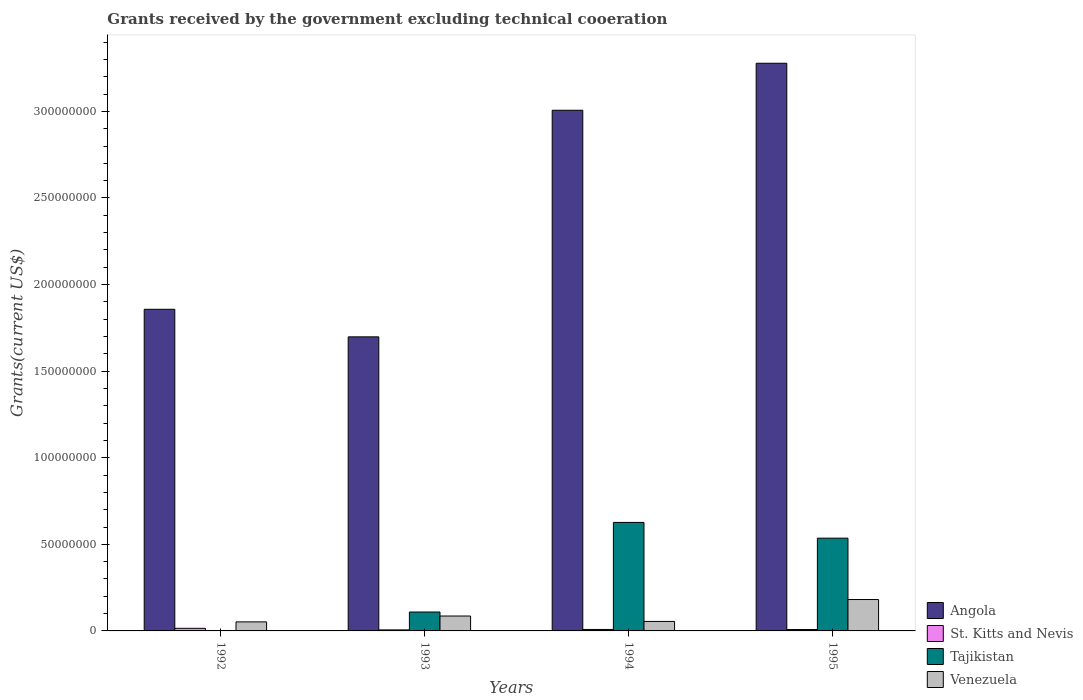How many different coloured bars are there?
Make the answer very short. 4. How many groups of bars are there?
Keep it short and to the point. 4. Are the number of bars per tick equal to the number of legend labels?
Your answer should be very brief. Yes. How many bars are there on the 3rd tick from the left?
Your answer should be compact. 4. How many bars are there on the 2nd tick from the right?
Your response must be concise. 4. What is the label of the 4th group of bars from the left?
Your answer should be very brief. 1995. In how many cases, is the number of bars for a given year not equal to the number of legend labels?
Provide a succinct answer. 0. What is the total grants received by the government in Venezuela in 1995?
Provide a short and direct response. 1.81e+07. Across all years, what is the maximum total grants received by the government in Angola?
Provide a short and direct response. 3.28e+08. Across all years, what is the minimum total grants received by the government in St. Kitts and Nevis?
Offer a terse response. 5.90e+05. In which year was the total grants received by the government in Angola maximum?
Your answer should be compact. 1995. What is the total total grants received by the government in Angola in the graph?
Your response must be concise. 9.84e+08. What is the difference between the total grants received by the government in St. Kitts and Nevis in 1992 and that in 1993?
Make the answer very short. 9.20e+05. What is the difference between the total grants received by the government in Venezuela in 1993 and the total grants received by the government in St. Kitts and Nevis in 1994?
Provide a short and direct response. 7.76e+06. What is the average total grants received by the government in Angola per year?
Provide a short and direct response. 2.46e+08. In the year 1993, what is the difference between the total grants received by the government in Tajikistan and total grants received by the government in St. Kitts and Nevis?
Make the answer very short. 1.03e+07. What is the ratio of the total grants received by the government in Venezuela in 1993 to that in 1994?
Your answer should be compact. 1.57. Is the total grants received by the government in Angola in 1992 less than that in 1995?
Keep it short and to the point. Yes. What is the difference between the highest and the second highest total grants received by the government in Venezuela?
Your answer should be compact. 9.53e+06. What is the difference between the highest and the lowest total grants received by the government in St. Kitts and Nevis?
Provide a short and direct response. 9.20e+05. What does the 1st bar from the left in 1993 represents?
Offer a terse response. Angola. What does the 4th bar from the right in 1994 represents?
Ensure brevity in your answer.  Angola. Is it the case that in every year, the sum of the total grants received by the government in Venezuela and total grants received by the government in St. Kitts and Nevis is greater than the total grants received by the government in Angola?
Make the answer very short. No. Are all the bars in the graph horizontal?
Provide a short and direct response. No. What is the difference between two consecutive major ticks on the Y-axis?
Give a very brief answer. 5.00e+07. Does the graph contain grids?
Offer a terse response. No. How many legend labels are there?
Your response must be concise. 4. What is the title of the graph?
Keep it short and to the point. Grants received by the government excluding technical cooeration. What is the label or title of the Y-axis?
Offer a terse response. Grants(current US$). What is the Grants(current US$) of Angola in 1992?
Make the answer very short. 1.86e+08. What is the Grants(current US$) in St. Kitts and Nevis in 1992?
Offer a terse response. 1.51e+06. What is the Grants(current US$) in Venezuela in 1992?
Offer a very short reply. 5.22e+06. What is the Grants(current US$) in Angola in 1993?
Offer a terse response. 1.70e+08. What is the Grants(current US$) in St. Kitts and Nevis in 1993?
Your answer should be compact. 5.90e+05. What is the Grants(current US$) of Tajikistan in 1993?
Make the answer very short. 1.09e+07. What is the Grants(current US$) in Venezuela in 1993?
Offer a very short reply. 8.60e+06. What is the Grants(current US$) in Angola in 1994?
Offer a terse response. 3.01e+08. What is the Grants(current US$) in St. Kitts and Nevis in 1994?
Your answer should be very brief. 8.40e+05. What is the Grants(current US$) in Tajikistan in 1994?
Make the answer very short. 6.27e+07. What is the Grants(current US$) of Venezuela in 1994?
Your response must be concise. 5.48e+06. What is the Grants(current US$) in Angola in 1995?
Your answer should be very brief. 3.28e+08. What is the Grants(current US$) of St. Kitts and Nevis in 1995?
Offer a very short reply. 8.00e+05. What is the Grants(current US$) in Tajikistan in 1995?
Your response must be concise. 5.36e+07. What is the Grants(current US$) of Venezuela in 1995?
Make the answer very short. 1.81e+07. Across all years, what is the maximum Grants(current US$) in Angola?
Offer a terse response. 3.28e+08. Across all years, what is the maximum Grants(current US$) of St. Kitts and Nevis?
Your answer should be very brief. 1.51e+06. Across all years, what is the maximum Grants(current US$) of Tajikistan?
Provide a succinct answer. 6.27e+07. Across all years, what is the maximum Grants(current US$) in Venezuela?
Ensure brevity in your answer.  1.81e+07. Across all years, what is the minimum Grants(current US$) of Angola?
Give a very brief answer. 1.70e+08. Across all years, what is the minimum Grants(current US$) of St. Kitts and Nevis?
Your response must be concise. 5.90e+05. Across all years, what is the minimum Grants(current US$) of Venezuela?
Your response must be concise. 5.22e+06. What is the total Grants(current US$) in Angola in the graph?
Your answer should be very brief. 9.84e+08. What is the total Grants(current US$) of St. Kitts and Nevis in the graph?
Your response must be concise. 3.74e+06. What is the total Grants(current US$) of Tajikistan in the graph?
Your response must be concise. 1.27e+08. What is the total Grants(current US$) of Venezuela in the graph?
Your response must be concise. 3.74e+07. What is the difference between the Grants(current US$) in Angola in 1992 and that in 1993?
Make the answer very short. 1.59e+07. What is the difference between the Grants(current US$) of St. Kitts and Nevis in 1992 and that in 1993?
Your answer should be very brief. 9.20e+05. What is the difference between the Grants(current US$) of Tajikistan in 1992 and that in 1993?
Your answer should be very brief. -1.07e+07. What is the difference between the Grants(current US$) in Venezuela in 1992 and that in 1993?
Your answer should be compact. -3.38e+06. What is the difference between the Grants(current US$) in Angola in 1992 and that in 1994?
Your answer should be compact. -1.15e+08. What is the difference between the Grants(current US$) in St. Kitts and Nevis in 1992 and that in 1994?
Your response must be concise. 6.70e+05. What is the difference between the Grants(current US$) in Tajikistan in 1992 and that in 1994?
Offer a very short reply. -6.24e+07. What is the difference between the Grants(current US$) in Venezuela in 1992 and that in 1994?
Your response must be concise. -2.60e+05. What is the difference between the Grants(current US$) in Angola in 1992 and that in 1995?
Your answer should be compact. -1.42e+08. What is the difference between the Grants(current US$) in St. Kitts and Nevis in 1992 and that in 1995?
Provide a short and direct response. 7.10e+05. What is the difference between the Grants(current US$) in Tajikistan in 1992 and that in 1995?
Offer a terse response. -5.33e+07. What is the difference between the Grants(current US$) of Venezuela in 1992 and that in 1995?
Offer a terse response. -1.29e+07. What is the difference between the Grants(current US$) of Angola in 1993 and that in 1994?
Offer a terse response. -1.31e+08. What is the difference between the Grants(current US$) of St. Kitts and Nevis in 1993 and that in 1994?
Provide a short and direct response. -2.50e+05. What is the difference between the Grants(current US$) in Tajikistan in 1993 and that in 1994?
Make the answer very short. -5.18e+07. What is the difference between the Grants(current US$) of Venezuela in 1993 and that in 1994?
Your response must be concise. 3.12e+06. What is the difference between the Grants(current US$) in Angola in 1993 and that in 1995?
Keep it short and to the point. -1.58e+08. What is the difference between the Grants(current US$) of Tajikistan in 1993 and that in 1995?
Ensure brevity in your answer.  -4.26e+07. What is the difference between the Grants(current US$) of Venezuela in 1993 and that in 1995?
Your response must be concise. -9.53e+06. What is the difference between the Grants(current US$) of Angola in 1994 and that in 1995?
Ensure brevity in your answer.  -2.71e+07. What is the difference between the Grants(current US$) in St. Kitts and Nevis in 1994 and that in 1995?
Provide a short and direct response. 4.00e+04. What is the difference between the Grants(current US$) in Tajikistan in 1994 and that in 1995?
Your response must be concise. 9.10e+06. What is the difference between the Grants(current US$) in Venezuela in 1994 and that in 1995?
Provide a short and direct response. -1.26e+07. What is the difference between the Grants(current US$) of Angola in 1992 and the Grants(current US$) of St. Kitts and Nevis in 1993?
Provide a short and direct response. 1.85e+08. What is the difference between the Grants(current US$) in Angola in 1992 and the Grants(current US$) in Tajikistan in 1993?
Offer a terse response. 1.75e+08. What is the difference between the Grants(current US$) in Angola in 1992 and the Grants(current US$) in Venezuela in 1993?
Keep it short and to the point. 1.77e+08. What is the difference between the Grants(current US$) in St. Kitts and Nevis in 1992 and the Grants(current US$) in Tajikistan in 1993?
Provide a succinct answer. -9.40e+06. What is the difference between the Grants(current US$) of St. Kitts and Nevis in 1992 and the Grants(current US$) of Venezuela in 1993?
Your answer should be compact. -7.09e+06. What is the difference between the Grants(current US$) in Tajikistan in 1992 and the Grants(current US$) in Venezuela in 1993?
Ensure brevity in your answer.  -8.35e+06. What is the difference between the Grants(current US$) of Angola in 1992 and the Grants(current US$) of St. Kitts and Nevis in 1994?
Keep it short and to the point. 1.85e+08. What is the difference between the Grants(current US$) of Angola in 1992 and the Grants(current US$) of Tajikistan in 1994?
Provide a short and direct response. 1.23e+08. What is the difference between the Grants(current US$) in Angola in 1992 and the Grants(current US$) in Venezuela in 1994?
Provide a succinct answer. 1.80e+08. What is the difference between the Grants(current US$) in St. Kitts and Nevis in 1992 and the Grants(current US$) in Tajikistan in 1994?
Give a very brief answer. -6.12e+07. What is the difference between the Grants(current US$) of St. Kitts and Nevis in 1992 and the Grants(current US$) of Venezuela in 1994?
Your response must be concise. -3.97e+06. What is the difference between the Grants(current US$) of Tajikistan in 1992 and the Grants(current US$) of Venezuela in 1994?
Make the answer very short. -5.23e+06. What is the difference between the Grants(current US$) in Angola in 1992 and the Grants(current US$) in St. Kitts and Nevis in 1995?
Provide a succinct answer. 1.85e+08. What is the difference between the Grants(current US$) in Angola in 1992 and the Grants(current US$) in Tajikistan in 1995?
Your response must be concise. 1.32e+08. What is the difference between the Grants(current US$) of Angola in 1992 and the Grants(current US$) of Venezuela in 1995?
Your answer should be very brief. 1.68e+08. What is the difference between the Grants(current US$) in St. Kitts and Nevis in 1992 and the Grants(current US$) in Tajikistan in 1995?
Provide a short and direct response. -5.20e+07. What is the difference between the Grants(current US$) in St. Kitts and Nevis in 1992 and the Grants(current US$) in Venezuela in 1995?
Your answer should be compact. -1.66e+07. What is the difference between the Grants(current US$) of Tajikistan in 1992 and the Grants(current US$) of Venezuela in 1995?
Your answer should be compact. -1.79e+07. What is the difference between the Grants(current US$) in Angola in 1993 and the Grants(current US$) in St. Kitts and Nevis in 1994?
Offer a very short reply. 1.69e+08. What is the difference between the Grants(current US$) in Angola in 1993 and the Grants(current US$) in Tajikistan in 1994?
Ensure brevity in your answer.  1.07e+08. What is the difference between the Grants(current US$) of Angola in 1993 and the Grants(current US$) of Venezuela in 1994?
Give a very brief answer. 1.64e+08. What is the difference between the Grants(current US$) of St. Kitts and Nevis in 1993 and the Grants(current US$) of Tajikistan in 1994?
Provide a succinct answer. -6.21e+07. What is the difference between the Grants(current US$) in St. Kitts and Nevis in 1993 and the Grants(current US$) in Venezuela in 1994?
Offer a very short reply. -4.89e+06. What is the difference between the Grants(current US$) of Tajikistan in 1993 and the Grants(current US$) of Venezuela in 1994?
Your answer should be compact. 5.43e+06. What is the difference between the Grants(current US$) in Angola in 1993 and the Grants(current US$) in St. Kitts and Nevis in 1995?
Your answer should be very brief. 1.69e+08. What is the difference between the Grants(current US$) in Angola in 1993 and the Grants(current US$) in Tajikistan in 1995?
Your answer should be very brief. 1.16e+08. What is the difference between the Grants(current US$) in Angola in 1993 and the Grants(current US$) in Venezuela in 1995?
Keep it short and to the point. 1.52e+08. What is the difference between the Grants(current US$) of St. Kitts and Nevis in 1993 and the Grants(current US$) of Tajikistan in 1995?
Your answer should be very brief. -5.30e+07. What is the difference between the Grants(current US$) of St. Kitts and Nevis in 1993 and the Grants(current US$) of Venezuela in 1995?
Offer a terse response. -1.75e+07. What is the difference between the Grants(current US$) in Tajikistan in 1993 and the Grants(current US$) in Venezuela in 1995?
Offer a very short reply. -7.22e+06. What is the difference between the Grants(current US$) of Angola in 1994 and the Grants(current US$) of St. Kitts and Nevis in 1995?
Keep it short and to the point. 3.00e+08. What is the difference between the Grants(current US$) in Angola in 1994 and the Grants(current US$) in Tajikistan in 1995?
Provide a short and direct response. 2.47e+08. What is the difference between the Grants(current US$) of Angola in 1994 and the Grants(current US$) of Venezuela in 1995?
Offer a terse response. 2.83e+08. What is the difference between the Grants(current US$) in St. Kitts and Nevis in 1994 and the Grants(current US$) in Tajikistan in 1995?
Ensure brevity in your answer.  -5.27e+07. What is the difference between the Grants(current US$) in St. Kitts and Nevis in 1994 and the Grants(current US$) in Venezuela in 1995?
Ensure brevity in your answer.  -1.73e+07. What is the difference between the Grants(current US$) in Tajikistan in 1994 and the Grants(current US$) in Venezuela in 1995?
Your answer should be very brief. 4.45e+07. What is the average Grants(current US$) in Angola per year?
Your answer should be very brief. 2.46e+08. What is the average Grants(current US$) in St. Kitts and Nevis per year?
Give a very brief answer. 9.35e+05. What is the average Grants(current US$) of Tajikistan per year?
Your answer should be compact. 3.18e+07. What is the average Grants(current US$) in Venezuela per year?
Provide a short and direct response. 9.36e+06. In the year 1992, what is the difference between the Grants(current US$) of Angola and Grants(current US$) of St. Kitts and Nevis?
Ensure brevity in your answer.  1.84e+08. In the year 1992, what is the difference between the Grants(current US$) of Angola and Grants(current US$) of Tajikistan?
Your response must be concise. 1.85e+08. In the year 1992, what is the difference between the Grants(current US$) in Angola and Grants(current US$) in Venezuela?
Provide a succinct answer. 1.81e+08. In the year 1992, what is the difference between the Grants(current US$) in St. Kitts and Nevis and Grants(current US$) in Tajikistan?
Your answer should be very brief. 1.26e+06. In the year 1992, what is the difference between the Grants(current US$) in St. Kitts and Nevis and Grants(current US$) in Venezuela?
Your answer should be very brief. -3.71e+06. In the year 1992, what is the difference between the Grants(current US$) of Tajikistan and Grants(current US$) of Venezuela?
Provide a succinct answer. -4.97e+06. In the year 1993, what is the difference between the Grants(current US$) in Angola and Grants(current US$) in St. Kitts and Nevis?
Ensure brevity in your answer.  1.69e+08. In the year 1993, what is the difference between the Grants(current US$) of Angola and Grants(current US$) of Tajikistan?
Provide a short and direct response. 1.59e+08. In the year 1993, what is the difference between the Grants(current US$) in Angola and Grants(current US$) in Venezuela?
Ensure brevity in your answer.  1.61e+08. In the year 1993, what is the difference between the Grants(current US$) of St. Kitts and Nevis and Grants(current US$) of Tajikistan?
Offer a very short reply. -1.03e+07. In the year 1993, what is the difference between the Grants(current US$) of St. Kitts and Nevis and Grants(current US$) of Venezuela?
Give a very brief answer. -8.01e+06. In the year 1993, what is the difference between the Grants(current US$) of Tajikistan and Grants(current US$) of Venezuela?
Keep it short and to the point. 2.31e+06. In the year 1994, what is the difference between the Grants(current US$) of Angola and Grants(current US$) of St. Kitts and Nevis?
Your answer should be compact. 3.00e+08. In the year 1994, what is the difference between the Grants(current US$) of Angola and Grants(current US$) of Tajikistan?
Your answer should be very brief. 2.38e+08. In the year 1994, what is the difference between the Grants(current US$) of Angola and Grants(current US$) of Venezuela?
Your response must be concise. 2.95e+08. In the year 1994, what is the difference between the Grants(current US$) in St. Kitts and Nevis and Grants(current US$) in Tajikistan?
Offer a terse response. -6.18e+07. In the year 1994, what is the difference between the Grants(current US$) of St. Kitts and Nevis and Grants(current US$) of Venezuela?
Offer a very short reply. -4.64e+06. In the year 1994, what is the difference between the Grants(current US$) in Tajikistan and Grants(current US$) in Venezuela?
Offer a very short reply. 5.72e+07. In the year 1995, what is the difference between the Grants(current US$) of Angola and Grants(current US$) of St. Kitts and Nevis?
Your answer should be compact. 3.27e+08. In the year 1995, what is the difference between the Grants(current US$) of Angola and Grants(current US$) of Tajikistan?
Provide a short and direct response. 2.74e+08. In the year 1995, what is the difference between the Grants(current US$) in Angola and Grants(current US$) in Venezuela?
Offer a terse response. 3.10e+08. In the year 1995, what is the difference between the Grants(current US$) of St. Kitts and Nevis and Grants(current US$) of Tajikistan?
Your answer should be very brief. -5.28e+07. In the year 1995, what is the difference between the Grants(current US$) of St. Kitts and Nevis and Grants(current US$) of Venezuela?
Ensure brevity in your answer.  -1.73e+07. In the year 1995, what is the difference between the Grants(current US$) of Tajikistan and Grants(current US$) of Venezuela?
Provide a short and direct response. 3.54e+07. What is the ratio of the Grants(current US$) of Angola in 1992 to that in 1993?
Provide a short and direct response. 1.09. What is the ratio of the Grants(current US$) in St. Kitts and Nevis in 1992 to that in 1993?
Offer a very short reply. 2.56. What is the ratio of the Grants(current US$) of Tajikistan in 1992 to that in 1993?
Keep it short and to the point. 0.02. What is the ratio of the Grants(current US$) in Venezuela in 1992 to that in 1993?
Your response must be concise. 0.61. What is the ratio of the Grants(current US$) in Angola in 1992 to that in 1994?
Give a very brief answer. 0.62. What is the ratio of the Grants(current US$) in St. Kitts and Nevis in 1992 to that in 1994?
Your response must be concise. 1.8. What is the ratio of the Grants(current US$) in Tajikistan in 1992 to that in 1994?
Offer a terse response. 0. What is the ratio of the Grants(current US$) in Venezuela in 1992 to that in 1994?
Give a very brief answer. 0.95. What is the ratio of the Grants(current US$) in Angola in 1992 to that in 1995?
Provide a short and direct response. 0.57. What is the ratio of the Grants(current US$) in St. Kitts and Nevis in 1992 to that in 1995?
Ensure brevity in your answer.  1.89. What is the ratio of the Grants(current US$) of Tajikistan in 1992 to that in 1995?
Keep it short and to the point. 0. What is the ratio of the Grants(current US$) of Venezuela in 1992 to that in 1995?
Your answer should be very brief. 0.29. What is the ratio of the Grants(current US$) of Angola in 1993 to that in 1994?
Your answer should be very brief. 0.56. What is the ratio of the Grants(current US$) in St. Kitts and Nevis in 1993 to that in 1994?
Offer a terse response. 0.7. What is the ratio of the Grants(current US$) of Tajikistan in 1993 to that in 1994?
Provide a short and direct response. 0.17. What is the ratio of the Grants(current US$) of Venezuela in 1993 to that in 1994?
Offer a very short reply. 1.57. What is the ratio of the Grants(current US$) of Angola in 1993 to that in 1995?
Your answer should be compact. 0.52. What is the ratio of the Grants(current US$) of St. Kitts and Nevis in 1993 to that in 1995?
Offer a terse response. 0.74. What is the ratio of the Grants(current US$) of Tajikistan in 1993 to that in 1995?
Provide a succinct answer. 0.2. What is the ratio of the Grants(current US$) of Venezuela in 1993 to that in 1995?
Provide a succinct answer. 0.47. What is the ratio of the Grants(current US$) of Angola in 1994 to that in 1995?
Ensure brevity in your answer.  0.92. What is the ratio of the Grants(current US$) in St. Kitts and Nevis in 1994 to that in 1995?
Keep it short and to the point. 1.05. What is the ratio of the Grants(current US$) in Tajikistan in 1994 to that in 1995?
Provide a short and direct response. 1.17. What is the ratio of the Grants(current US$) in Venezuela in 1994 to that in 1995?
Provide a short and direct response. 0.3. What is the difference between the highest and the second highest Grants(current US$) in Angola?
Keep it short and to the point. 2.71e+07. What is the difference between the highest and the second highest Grants(current US$) of St. Kitts and Nevis?
Make the answer very short. 6.70e+05. What is the difference between the highest and the second highest Grants(current US$) of Tajikistan?
Provide a succinct answer. 9.10e+06. What is the difference between the highest and the second highest Grants(current US$) in Venezuela?
Offer a very short reply. 9.53e+06. What is the difference between the highest and the lowest Grants(current US$) in Angola?
Your answer should be very brief. 1.58e+08. What is the difference between the highest and the lowest Grants(current US$) of St. Kitts and Nevis?
Offer a very short reply. 9.20e+05. What is the difference between the highest and the lowest Grants(current US$) in Tajikistan?
Keep it short and to the point. 6.24e+07. What is the difference between the highest and the lowest Grants(current US$) in Venezuela?
Provide a short and direct response. 1.29e+07. 